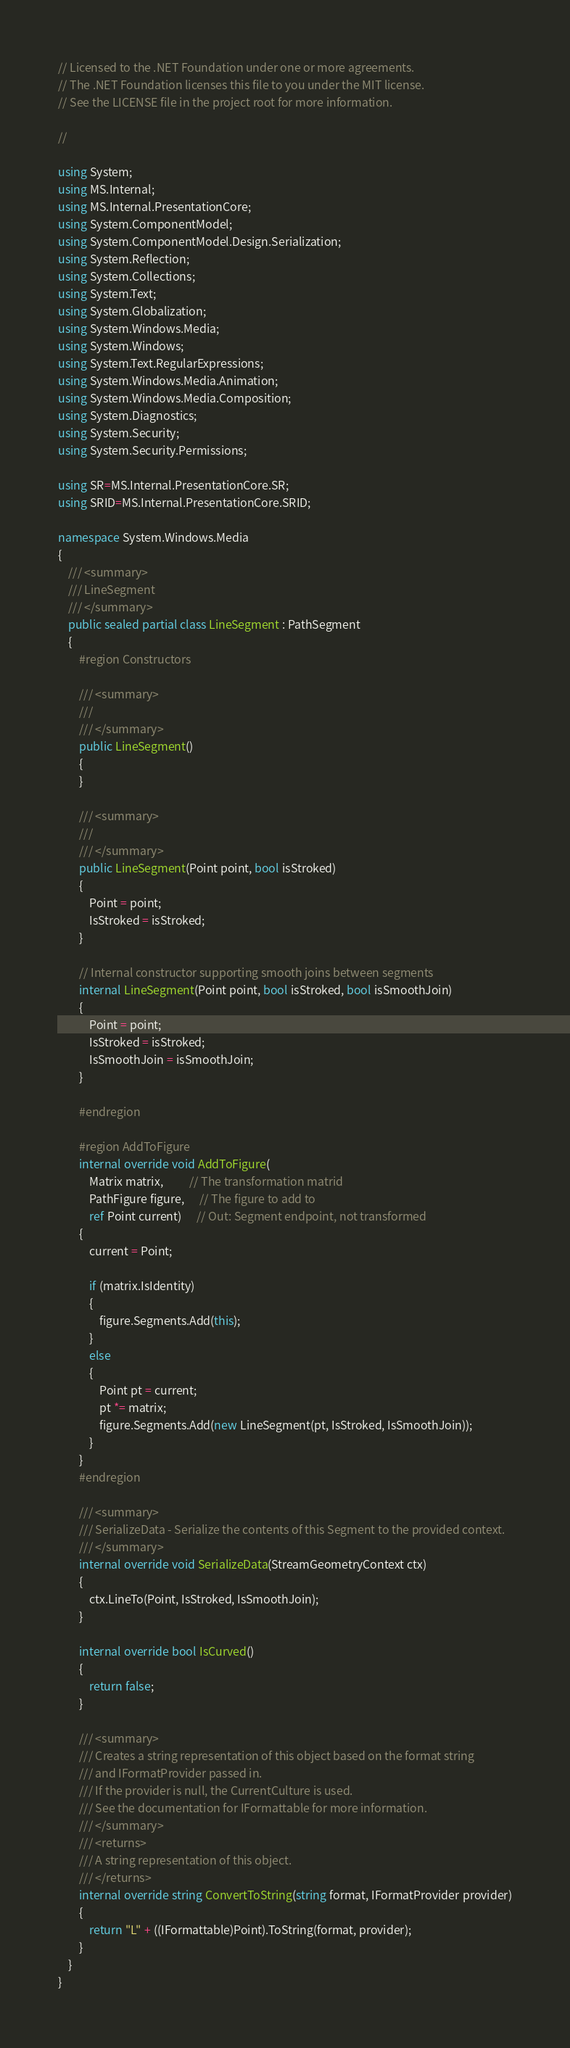<code> <loc_0><loc_0><loc_500><loc_500><_C#_>// Licensed to the .NET Foundation under one or more agreements.
// The .NET Foundation licenses this file to you under the MIT license.
// See the LICENSE file in the project root for more information.

//

using System;
using MS.Internal;
using MS.Internal.PresentationCore;
using System.ComponentModel;
using System.ComponentModel.Design.Serialization;
using System.Reflection;
using System.Collections;
using System.Text;
using System.Globalization;
using System.Windows.Media;
using System.Windows;
using System.Text.RegularExpressions;
using System.Windows.Media.Animation;
using System.Windows.Media.Composition;
using System.Diagnostics;
using System.Security;
using System.Security.Permissions;

using SR=MS.Internal.PresentationCore.SR;
using SRID=MS.Internal.PresentationCore.SRID;

namespace System.Windows.Media
{
    /// <summary>
    /// LineSegment
    /// </summary>
    public sealed partial class LineSegment : PathSegment
    {
        #region Constructors

        /// <summary>
        ///
        /// </summary>
        public LineSegment() 
        {
        }

        /// <summary>
        ///
        /// </summary>
        public LineSegment(Point point, bool isStroked)
        {
            Point = point;
            IsStroked = isStroked;
        }

        // Internal constructor supporting smooth joins between segments
        internal LineSegment(Point point, bool isStroked, bool isSmoothJoin)
        {
            Point = point;
            IsStroked = isStroked;
            IsSmoothJoin = isSmoothJoin;
        }

        #endregion

        #region AddToFigure
        internal override void AddToFigure(
            Matrix matrix,          // The transformation matrid
            PathFigure figure,      // The figure to add to
            ref Point current)      // Out: Segment endpoint, not transformed
        {
            current = Point;

            if (matrix.IsIdentity)
            {
                figure.Segments.Add(this);
            }
            else
            {
                Point pt = current;
                pt *= matrix;
                figure.Segments.Add(new LineSegment(pt, IsStroked, IsSmoothJoin));
            }
        }
        #endregion

        /// <summary>
        /// SerializeData - Serialize the contents of this Segment to the provided context.
        /// </summary>
        internal override void SerializeData(StreamGeometryContext ctx)
        {
            ctx.LineTo(Point, IsStroked, IsSmoothJoin);
        }
        
        internal override bool IsCurved()
        {
            return false;
        }

        /// <summary>
        /// Creates a string representation of this object based on the format string 
        /// and IFormatProvider passed in.  
        /// If the provider is null, the CurrentCulture is used.
        /// See the documentation for IFormattable for more information.
        /// </summary>
        /// <returns>
        /// A string representation of this object.
        /// </returns>
        internal override string ConvertToString(string format, IFormatProvider provider)
        {
            return "L" + ((IFormattable)Point).ToString(format, provider);
        }
    }
}

</code> 